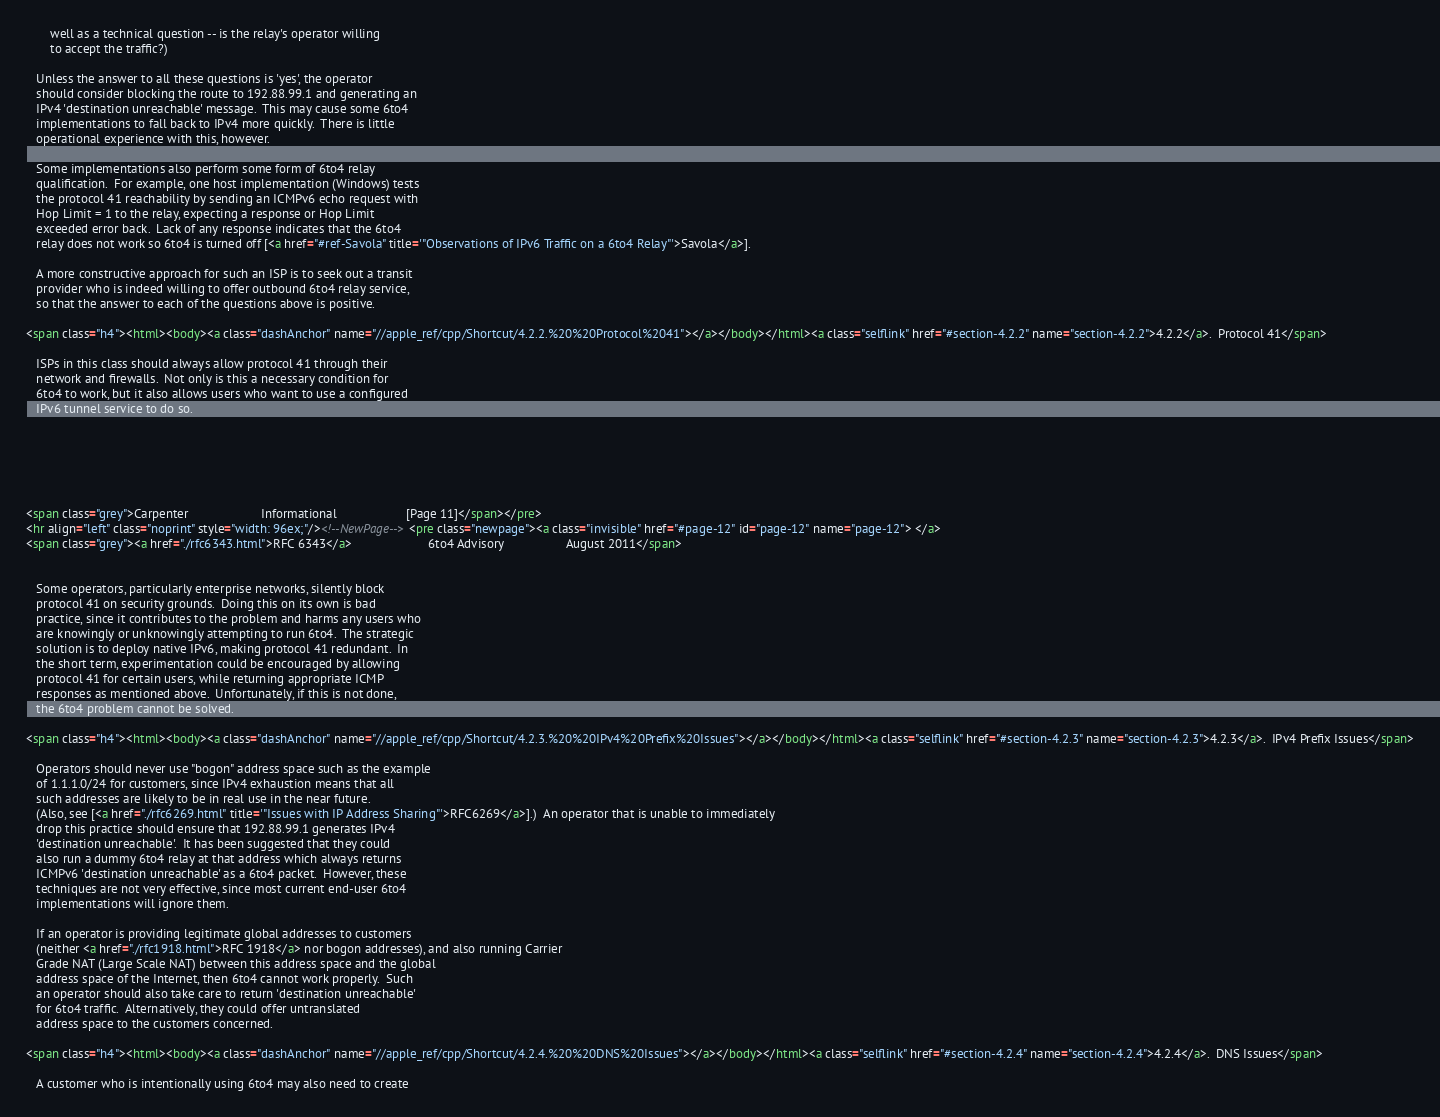Convert code to text. <code><loc_0><loc_0><loc_500><loc_500><_HTML_>       well as a technical question -- is the relay's operator willing
       to accept the traffic?)

   Unless the answer to all these questions is 'yes', the operator
   should consider blocking the route to 192.88.99.1 and generating an
   IPv4 'destination unreachable' message.  This may cause some 6to4
   implementations to fall back to IPv4 more quickly.  There is little
   operational experience with this, however.

   Some implementations also perform some form of 6to4 relay
   qualification.  For example, one host implementation (Windows) tests
   the protocol 41 reachability by sending an ICMPv6 echo request with
   Hop Limit = 1 to the relay, expecting a response or Hop Limit
   exceeded error back.  Lack of any response indicates that the 6to4
   relay does not work so 6to4 is turned off [<a href="#ref-Savola" title='"Observations of IPv6 Traffic on a 6to4 Relay"'>Savola</a>].

   A more constructive approach for such an ISP is to seek out a transit
   provider who is indeed willing to offer outbound 6to4 relay service,
   so that the answer to each of the questions above is positive.

<span class="h4"><html><body><a class="dashAnchor" name="//apple_ref/cpp/Shortcut/4.2.2.%20%20Protocol%2041"></a></body></html><a class="selflink" href="#section-4.2.2" name="section-4.2.2">4.2.2</a>.  Protocol 41</span>

   ISPs in this class should always allow protocol 41 through their
   network and firewalls.  Not only is this a necessary condition for
   6to4 to work, but it also allows users who want to use a configured
   IPv6 tunnel service to do so.






<span class="grey">Carpenter                     Informational                    [Page 11]</span></pre>
<hr align="left" class="noprint" style="width: 96ex;"/><!--NewPage--><pre class="newpage"><a class="invisible" href="#page-12" id="page-12" name="page-12"> </a>
<span class="grey"><a href="./rfc6343.html">RFC 6343</a>                      6to4 Advisory                  August 2011</span>


   Some operators, particularly enterprise networks, silently block
   protocol 41 on security grounds.  Doing this on its own is bad
   practice, since it contributes to the problem and harms any users who
   are knowingly or unknowingly attempting to run 6to4.  The strategic
   solution is to deploy native IPv6, making protocol 41 redundant.  In
   the short term, experimentation could be encouraged by allowing
   protocol 41 for certain users, while returning appropriate ICMP
   responses as mentioned above.  Unfortunately, if this is not done,
   the 6to4 problem cannot be solved.

<span class="h4"><html><body><a class="dashAnchor" name="//apple_ref/cpp/Shortcut/4.2.3.%20%20IPv4%20Prefix%20Issues"></a></body></html><a class="selflink" href="#section-4.2.3" name="section-4.2.3">4.2.3</a>.  IPv4 Prefix Issues</span>

   Operators should never use "bogon" address space such as the example
   of 1.1.1.0/24 for customers, since IPv4 exhaustion means that all
   such addresses are likely to be in real use in the near future.
   (Also, see [<a href="./rfc6269.html" title='"Issues with IP Address Sharing"'>RFC6269</a>].)  An operator that is unable to immediately
   drop this practice should ensure that 192.88.99.1 generates IPv4
   'destination unreachable'.  It has been suggested that they could
   also run a dummy 6to4 relay at that address which always returns
   ICMPv6 'destination unreachable' as a 6to4 packet.  However, these
   techniques are not very effective, since most current end-user 6to4
   implementations will ignore them.

   If an operator is providing legitimate global addresses to customers
   (neither <a href="./rfc1918.html">RFC 1918</a> nor bogon addresses), and also running Carrier
   Grade NAT (Large Scale NAT) between this address space and the global
   address space of the Internet, then 6to4 cannot work properly.  Such
   an operator should also take care to return 'destination unreachable'
   for 6to4 traffic.  Alternatively, they could offer untranslated
   address space to the customers concerned.

<span class="h4"><html><body><a class="dashAnchor" name="//apple_ref/cpp/Shortcut/4.2.4.%20%20DNS%20Issues"></a></body></html><a class="selflink" href="#section-4.2.4" name="section-4.2.4">4.2.4</a>.  DNS Issues</span>

   A customer who is intentionally using 6to4 may also need to create</code> 